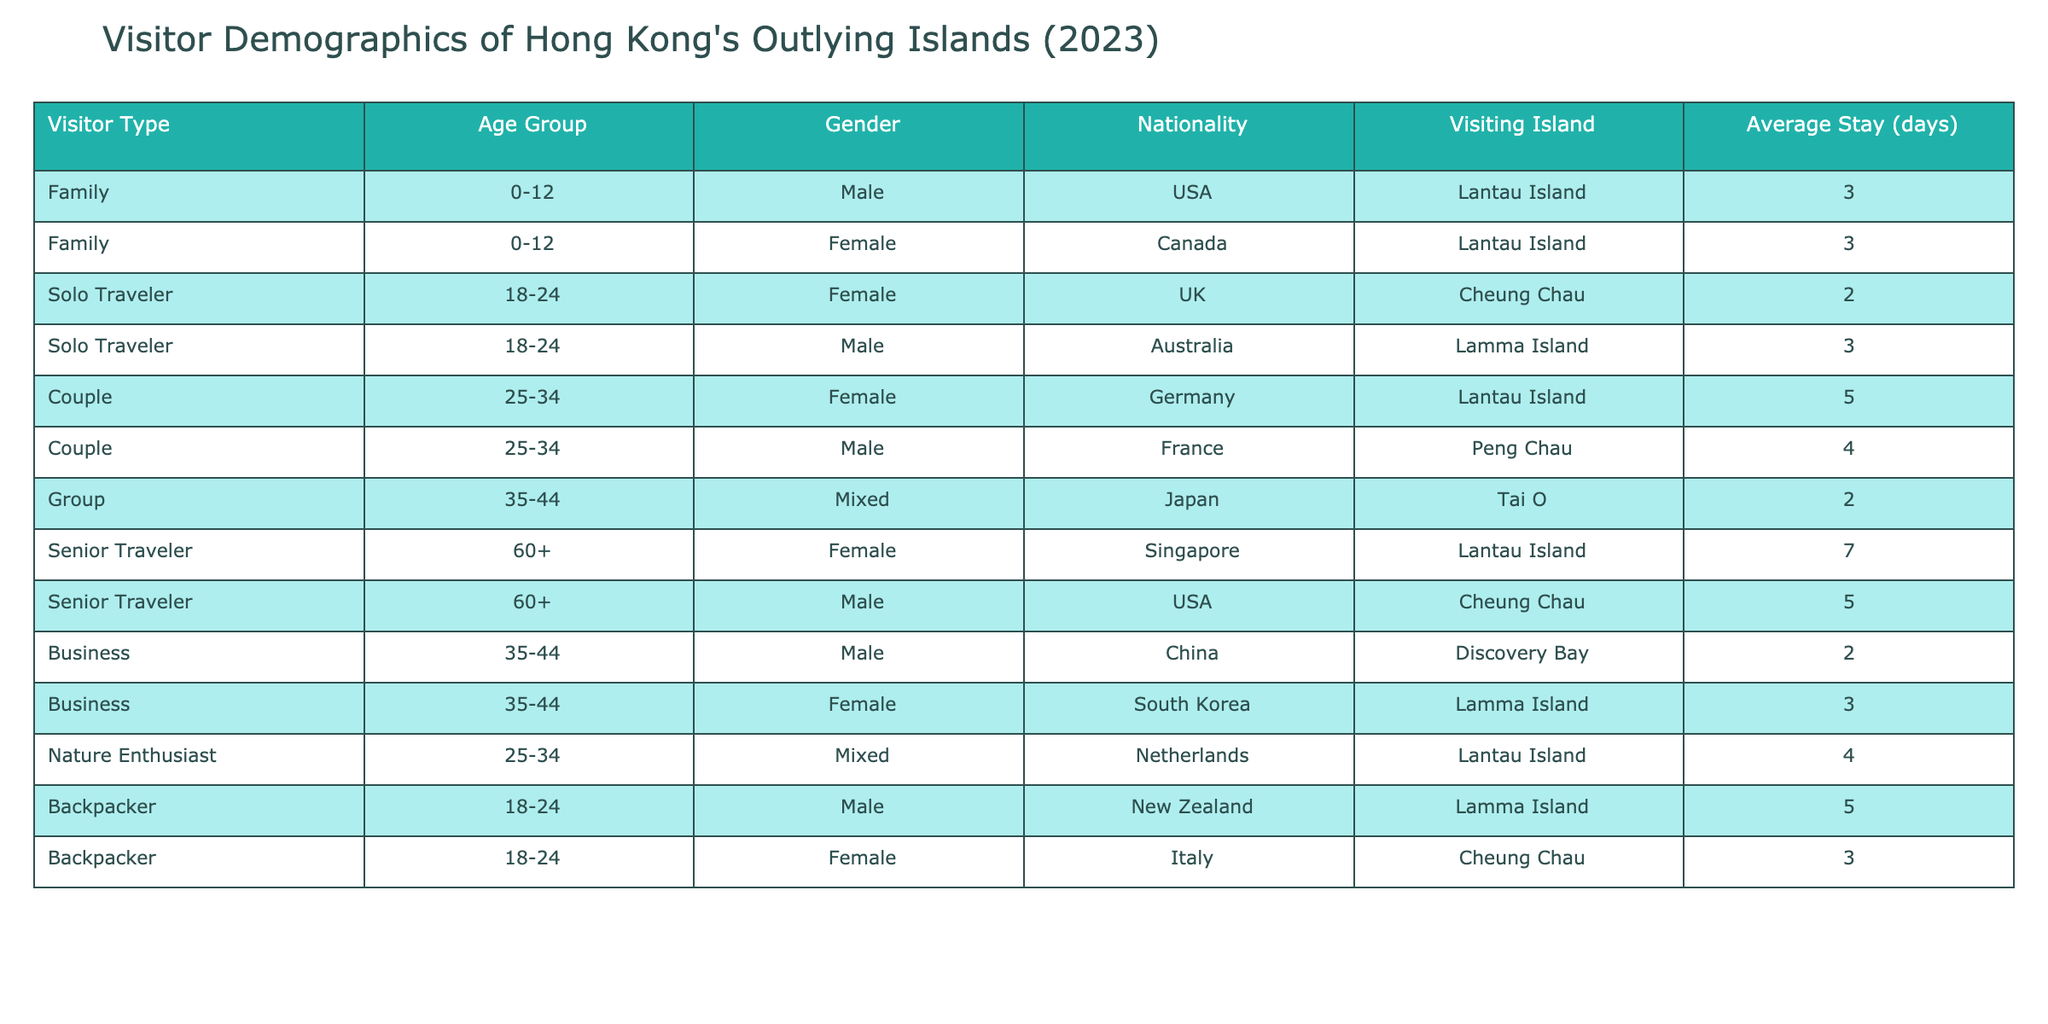What is the most common nationality among visitors? By counting the nationalities listed in the table, we can see that there are visitors from the USA, Canada, UK, Australia, Germany, France, Japan, Singapore, China, South Korea, Netherlands, New Zealand, and Italy. The USA appears twice, but no nationality appears more than twice, indicating that there isn't a single most common nationality among the visitors.
Answer: There is no single most common nationality What is the average stay duration for senior travelers? The data lists two senior travelers: one female from Singapore who stays for 7 days and one male from the USA who stays for 5 days. To find the average stay, we sum the days (7 + 5 = 12) and divide by the number of senior travelers (2), leading to an average stay of 12 / 2 = 6 days.
Answer: 6 days Is there a backpacker visiting Lantau Island? Looking through the table, we note the visiting islands for backpackers. The backpacker listed from New Zealand visits Lamma Island, while there is no entry for a backpacker visiting Lantau Island. Thus, the answer is no.
Answer: No How many couples are visiting Lantau Island, and what is their average stay? There is one couple visiting Lantau Island, specifically a female from Germany who stays for 5 days. Since there is only one couple, the average stay is directly the same as the duration of that visit.
Answer: 5 days What percentage of visitors are seniors? From the data, there are a total of 12 visitors listed. Among them, 2 are senior travelers, which makes the calculation straightforward: (2 / 12) * 100 = 16.67%. Therefore, the percentage of visitors who are seniors is approximately 16.67%.
Answer: 16.67% Are there any solo travelers visiting Peng Chau? Checking the table, we find solo travelers listed for Cheung Chau and Lamma Island, but there are no entries indicating a solo traveler is visiting Peng Chau. Therefore, the answer is no.
Answer: No What is the total number of days spent by business travelers? The table includes two business travelers: one male from China who stays for 2 days and one female from South Korea who stays for 3 days. By summing their stays (2 + 3), we get a total of 5 days spent by business travelers.
Answer: 5 days Which island has the highest average stay duration among visitors? Calculating the average stay for each island based on the visitors listed: Lantau Island has stays of 3, 5, 7, and 4 (average = 19 / 4 = 4.75), Cheung Chau has 2, 5, and 3 (average = 10 / 3 = 3.33), Lamma Island has 3, 2, 4, and 5 (average = 14 / 4 = 3.5), Tai O has 2 (average = 2), and Peng Chau has 4 (average = 4). The highest average stay is at Lantau Island with 4.75 days.
Answer: Lantau Island 